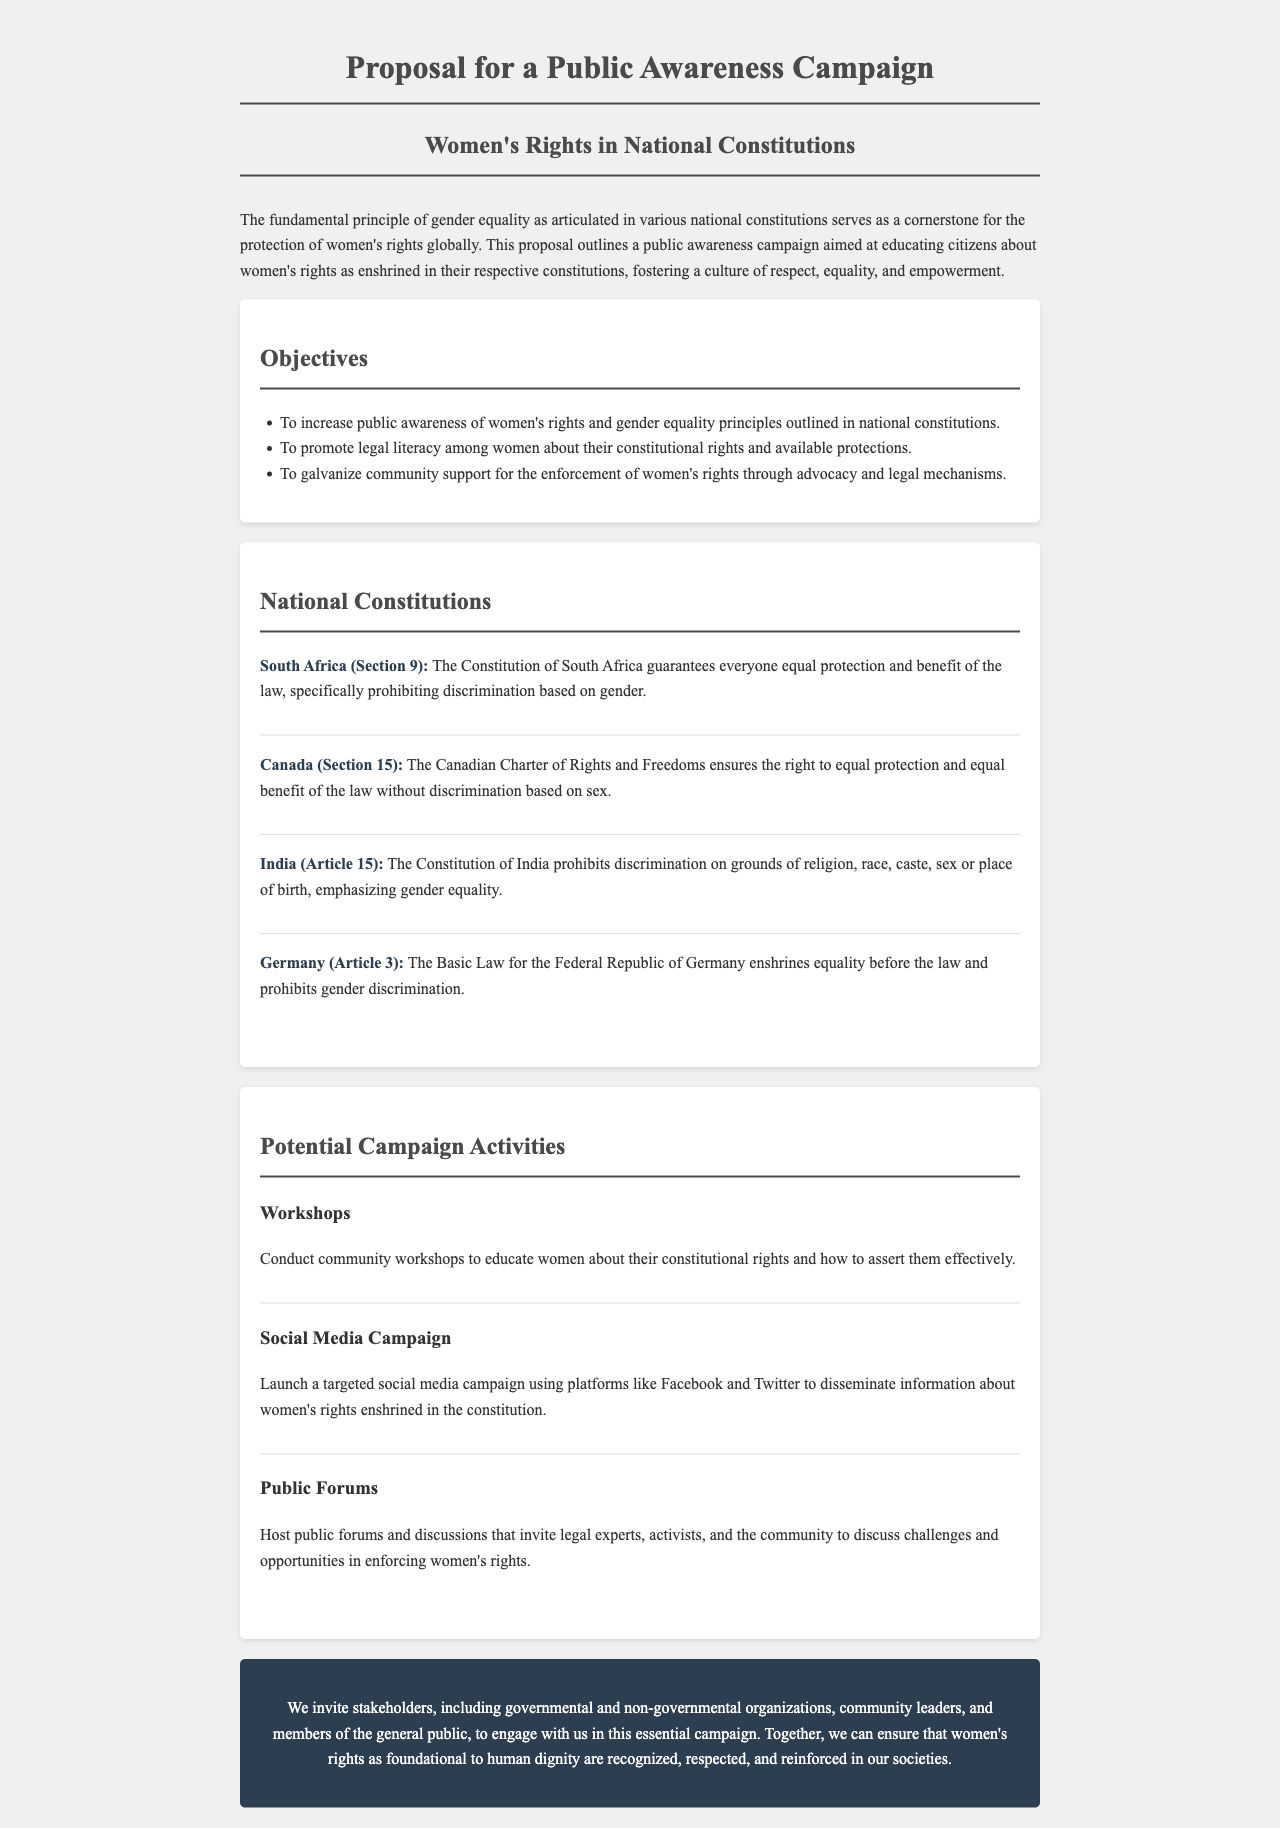What is the main focus of the proposed campaign? The campaign focuses on educating citizens about women's rights as enshrined in their respective constitutions.
Answer: women's rights Which country’s constitution prohibits discrimination based on gender in Section 9? This information is found in the "National Constitutions" section, specifically naming South Africa for Section 9.
Answer: South Africa What does Article 3 of Germany's Basic Law enshrine? It is stated that Article 3 enshrines equality before the law and prohibits gender discrimination.
Answer: equality before the law What is one of the objectives of the public awareness campaign? The objectives are listed under the "Objectives" section, where one is to promote legal literacy among women.
Answer: promote legal literacy How many potential campaign activities are listed in the document? The activities are detailed under the "Potential Campaign Activities" section, which lists three activities.
Answer: three What is one activity proposed to educate women about their constitutional rights? One of the activities mentioned is conducting community workshops.
Answer: community workshops Which section addresses the call to action in the proposal? The "call-to-action" section invites stakeholders to engage in the campaign.
Answer: call-to-action What audience is specifically mentioned for the campaign's invitation? The audience includes governmental and non-governmental organizations and community leaders.
Answer: governmental and non-governmental organizations 